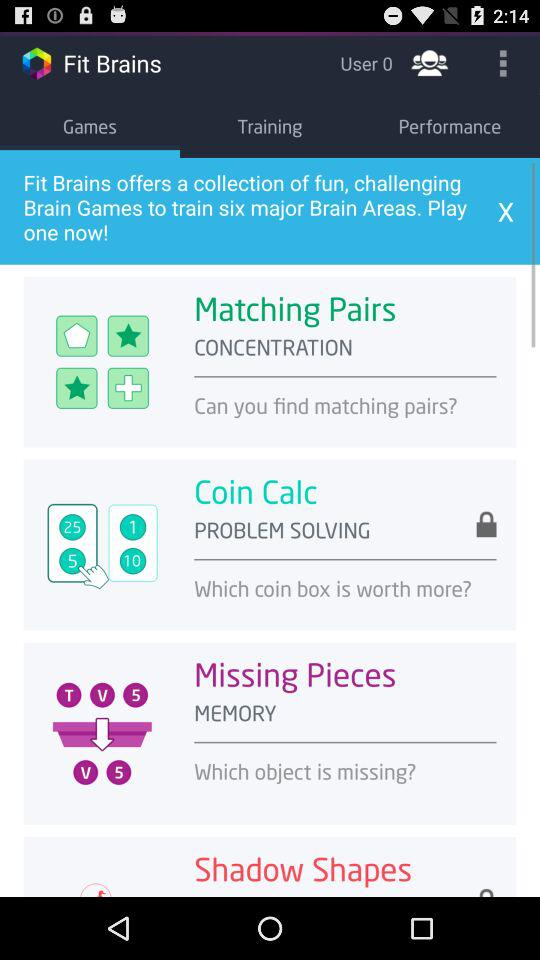What is the name of the application? The name of the application is "Fit Brains". 